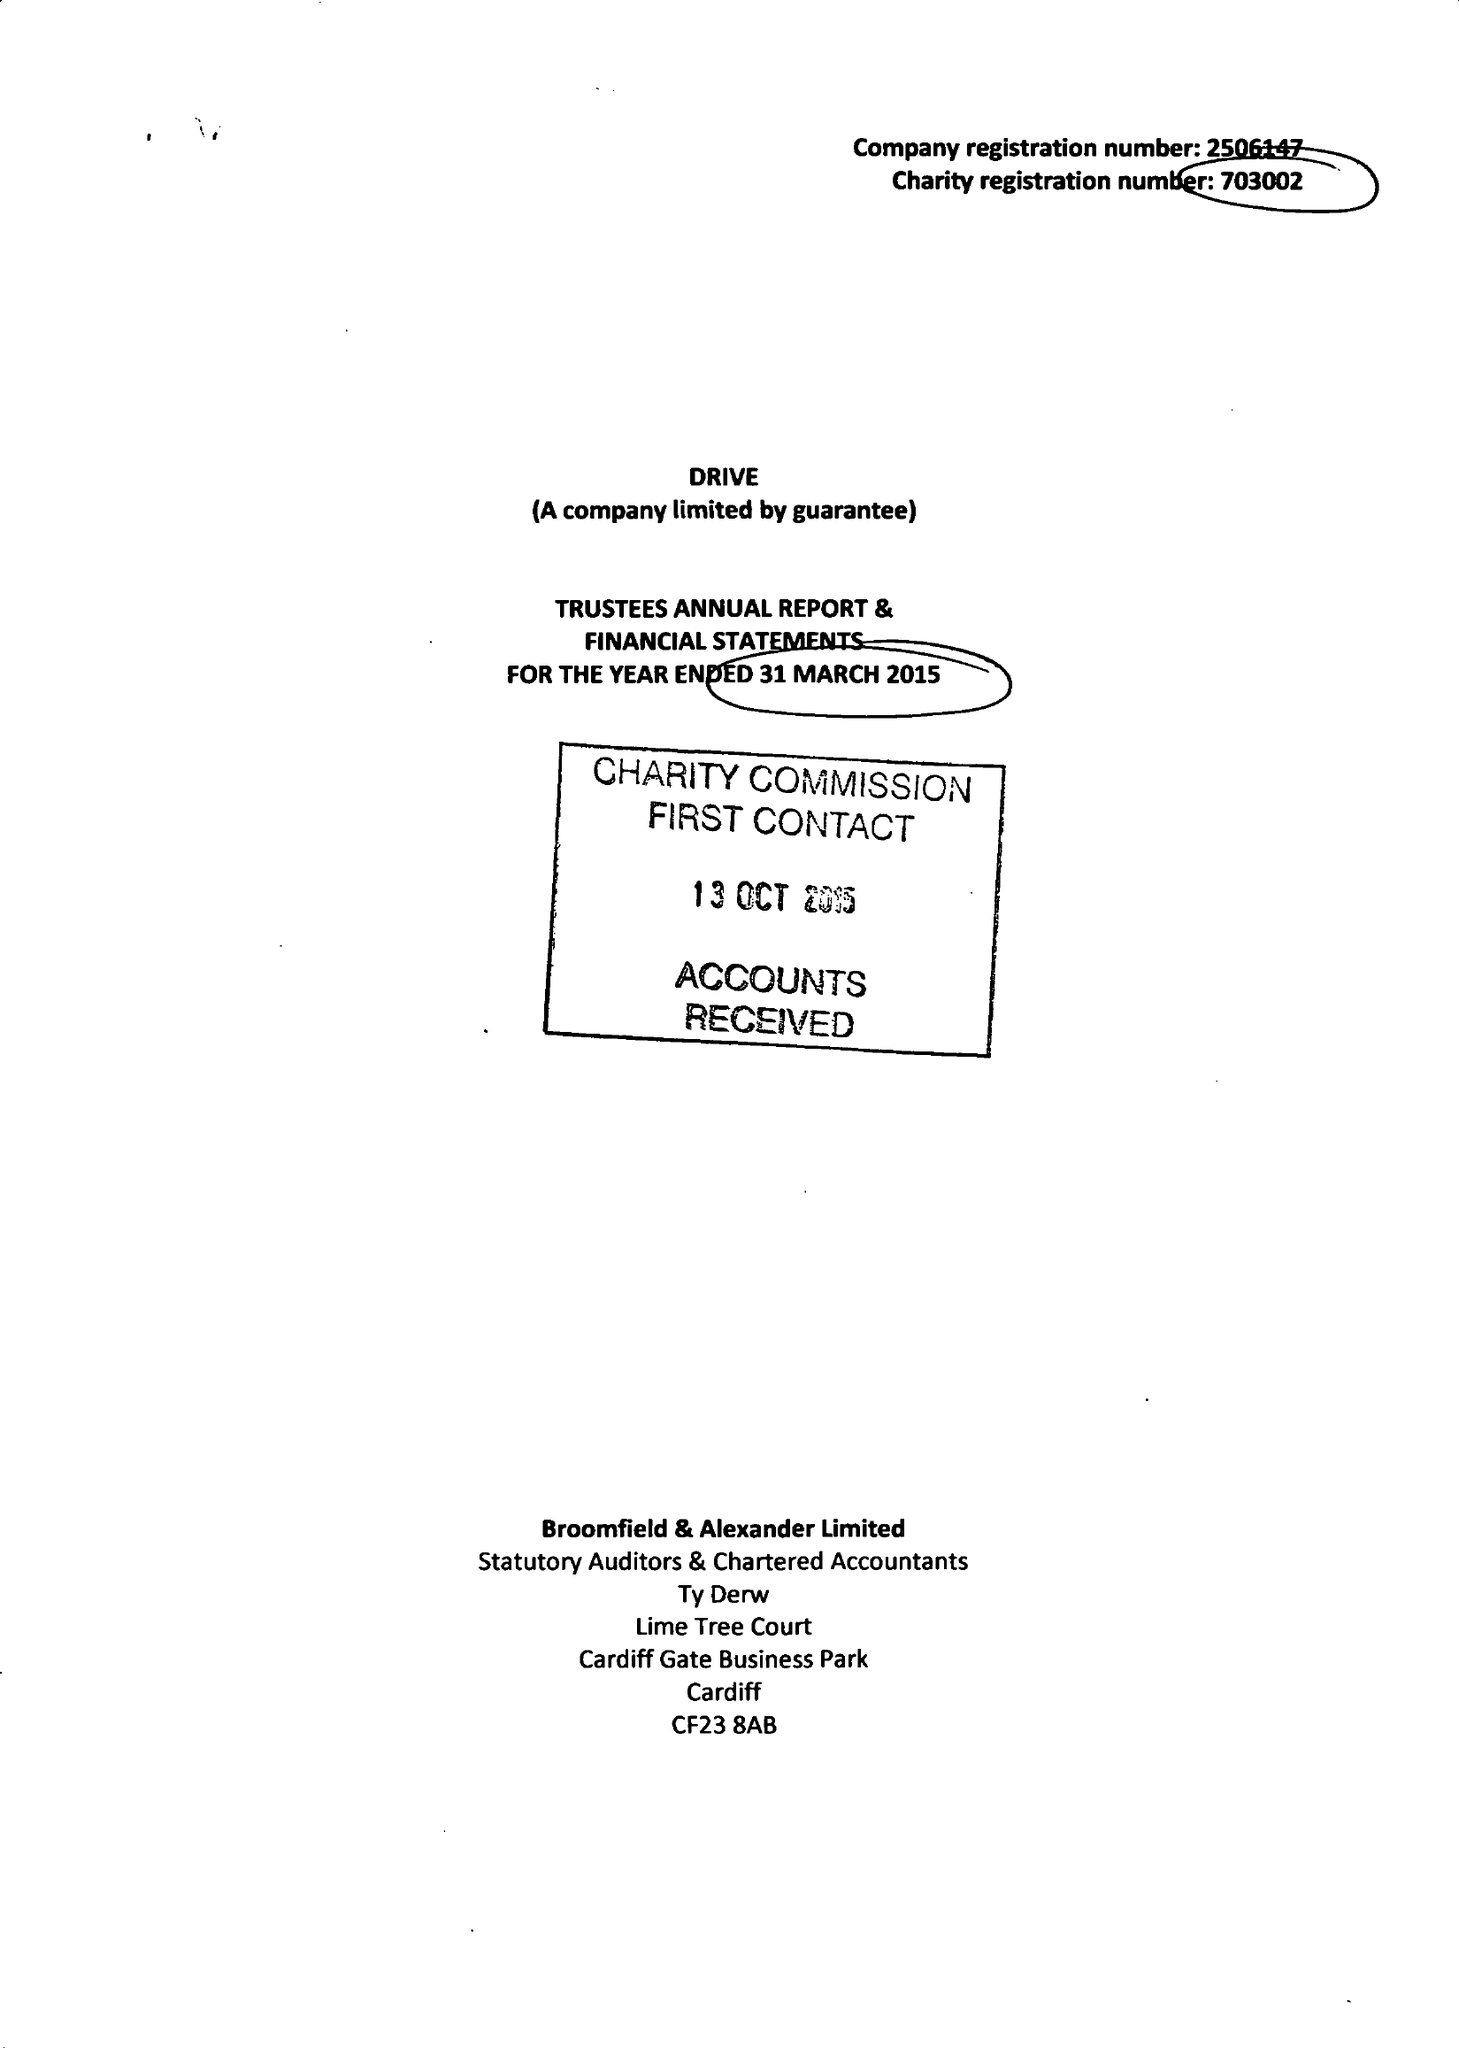What is the value for the income_annually_in_british_pounds?
Answer the question using a single word or phrase. 11403989.00 